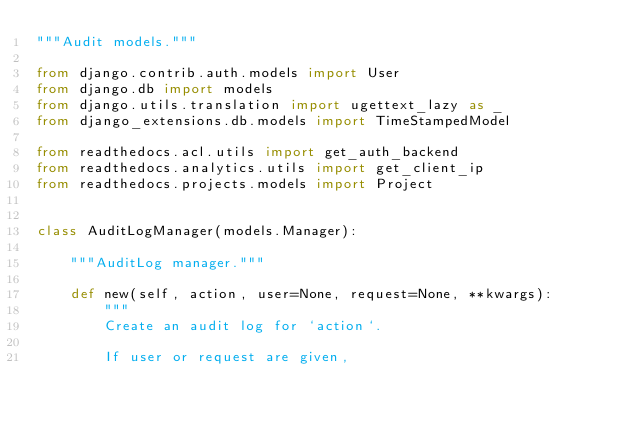Convert code to text. <code><loc_0><loc_0><loc_500><loc_500><_Python_>"""Audit models."""

from django.contrib.auth.models import User
from django.db import models
from django.utils.translation import ugettext_lazy as _
from django_extensions.db.models import TimeStampedModel

from readthedocs.acl.utils import get_auth_backend
from readthedocs.analytics.utils import get_client_ip
from readthedocs.projects.models import Project


class AuditLogManager(models.Manager):

    """AuditLog manager."""

    def new(self, action, user=None, request=None, **kwargs):
        """
        Create an audit log for `action`.

        If user or request are given,</code> 